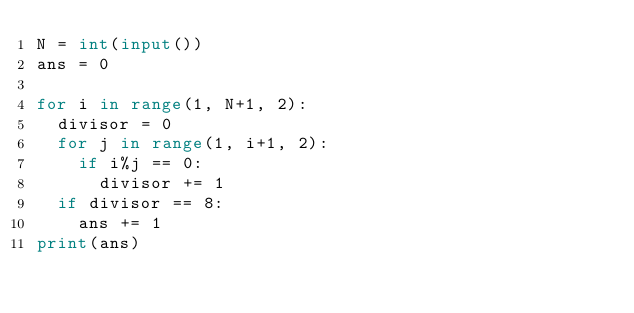<code> <loc_0><loc_0><loc_500><loc_500><_Python_>N = int(input())
ans = 0

for i in range(1, N+1, 2):
  divisor = 0
  for j in range(1, i+1, 2):
    if i%j == 0:
      divisor += 1
  if divisor == 8:
    ans += 1
print(ans)</code> 